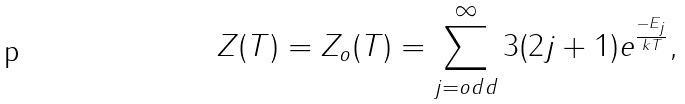<formula> <loc_0><loc_0><loc_500><loc_500>Z ( T ) = Z _ { o } ( T ) = \sum _ { j = o d d } ^ { \infty } 3 ( 2 j + 1 ) e ^ { \frac { - E _ { j } } { k T } } ,</formula> 